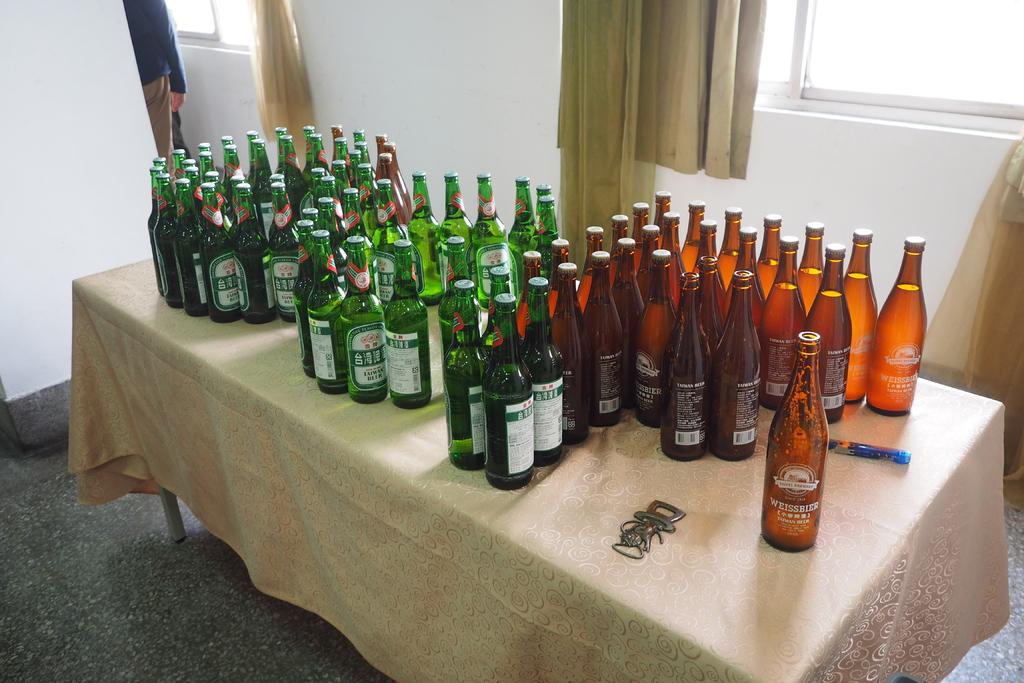What brand is on the brown bottle?
Ensure brevity in your answer.  Weissbier. 